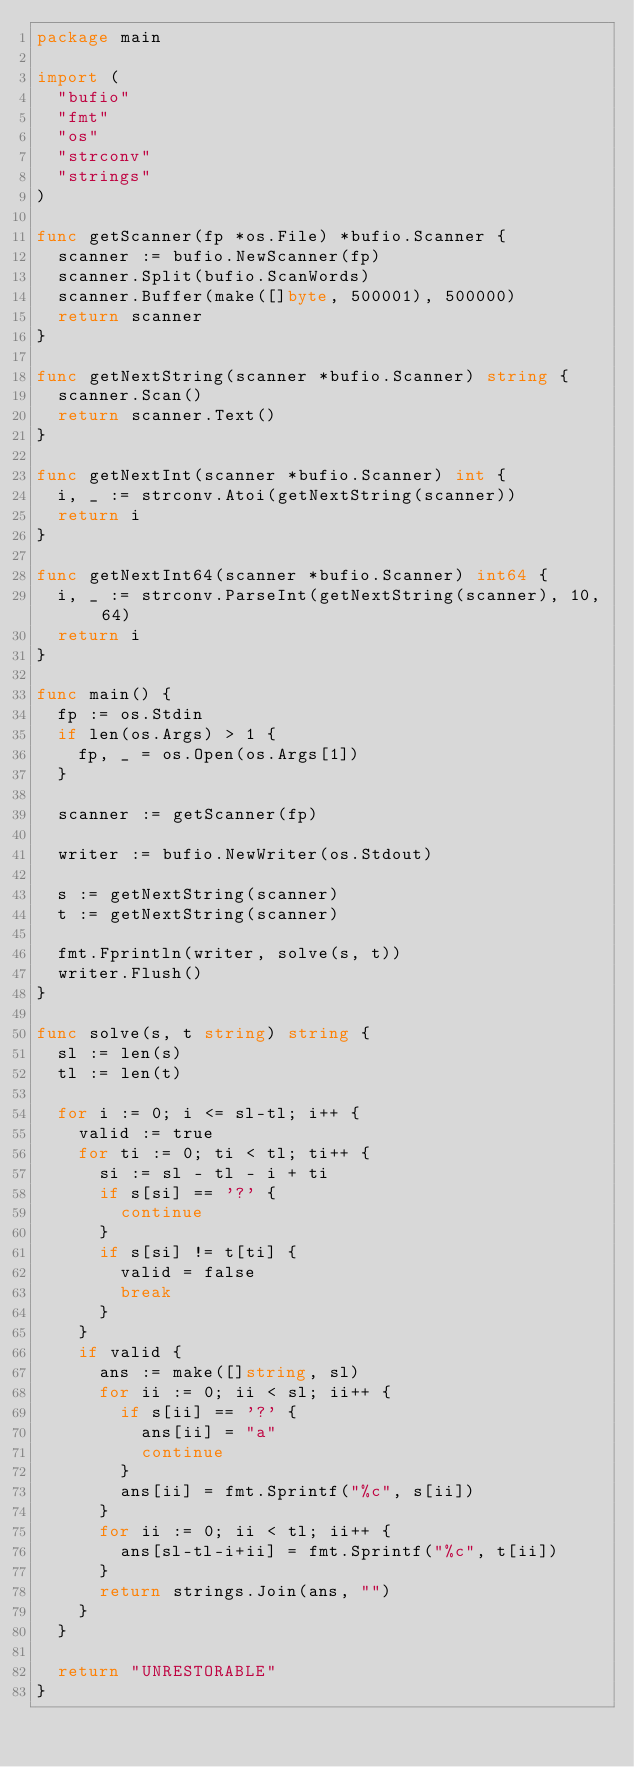<code> <loc_0><loc_0><loc_500><loc_500><_Go_>package main

import (
	"bufio"
	"fmt"
	"os"
	"strconv"
	"strings"
)

func getScanner(fp *os.File) *bufio.Scanner {
	scanner := bufio.NewScanner(fp)
	scanner.Split(bufio.ScanWords)
	scanner.Buffer(make([]byte, 500001), 500000)
	return scanner
}

func getNextString(scanner *bufio.Scanner) string {
	scanner.Scan()
	return scanner.Text()
}

func getNextInt(scanner *bufio.Scanner) int {
	i, _ := strconv.Atoi(getNextString(scanner))
	return i
}

func getNextInt64(scanner *bufio.Scanner) int64 {
	i, _ := strconv.ParseInt(getNextString(scanner), 10, 64)
	return i
}

func main() {
	fp := os.Stdin
	if len(os.Args) > 1 {
		fp, _ = os.Open(os.Args[1])
	}

	scanner := getScanner(fp)

	writer := bufio.NewWriter(os.Stdout)

	s := getNextString(scanner)
	t := getNextString(scanner)

	fmt.Fprintln(writer, solve(s, t))
	writer.Flush()
}

func solve(s, t string) string {
	sl := len(s)
	tl := len(t)

	for i := 0; i <= sl-tl; i++ {
		valid := true
		for ti := 0; ti < tl; ti++ {
			si := sl - tl - i + ti
			if s[si] == '?' {
				continue
			}
			if s[si] != t[ti] {
				valid = false
				break
			}
		}
		if valid {
			ans := make([]string, sl)
			for ii := 0; ii < sl; ii++ {
				if s[ii] == '?' {
					ans[ii] = "a"
					continue
				}
				ans[ii] = fmt.Sprintf("%c", s[ii])
			}
			for ii := 0; ii < tl; ii++ {
				ans[sl-tl-i+ii] = fmt.Sprintf("%c", t[ii])
			}
			return strings.Join(ans, "")
		}
	}

	return "UNRESTORABLE"
}
</code> 